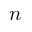<formula> <loc_0><loc_0><loc_500><loc_500>n</formula> 